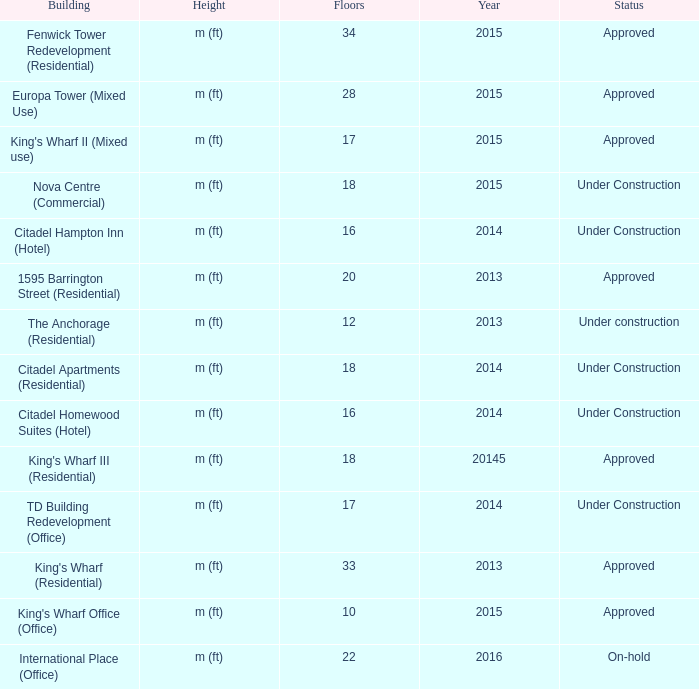What is the status of the building for 2014 with 33 floors? Approved. 